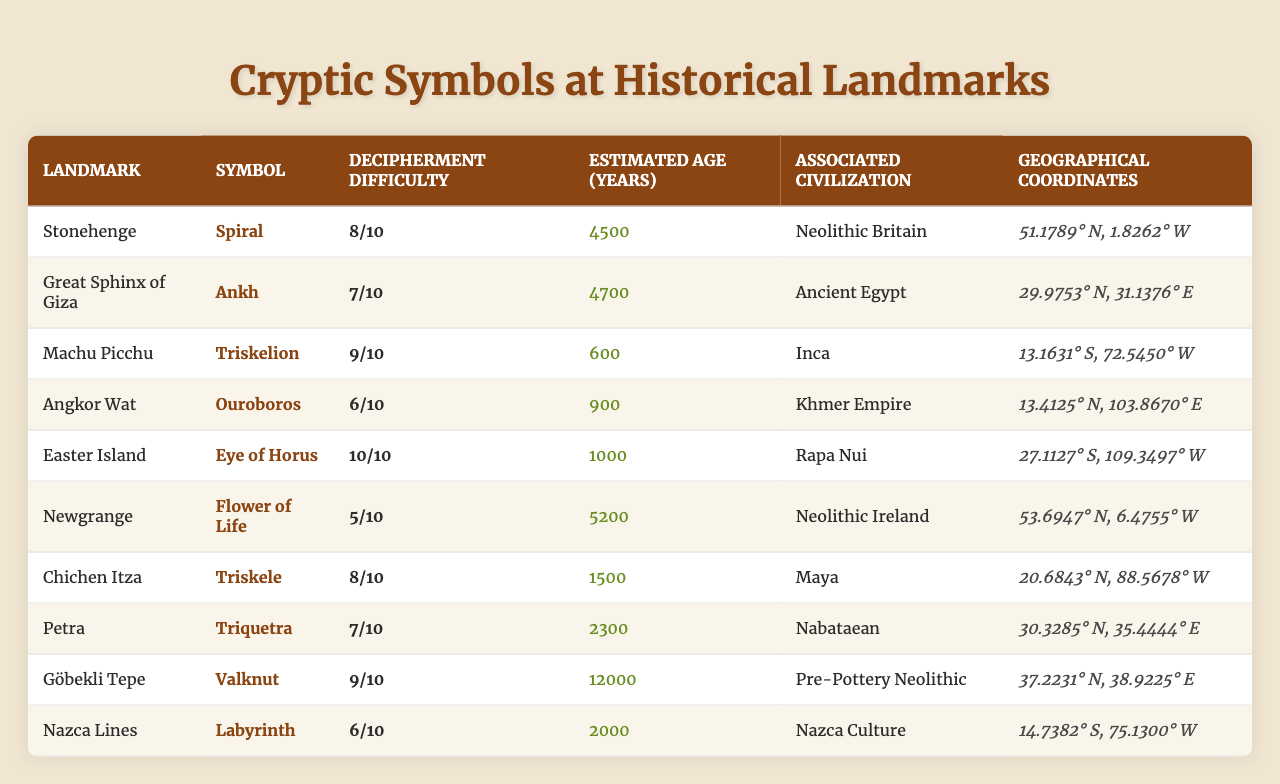What is the symbol associated with Machu Picchu? The table shows that the symbol next to Machu Picchu is "Triskelion".
Answer: Triskelion Which landmark has the highest decipherment difficulty? From the difficulties listed, the highest value is 10, which is associated with Easter Island.
Answer: Easter Island What is the average estimated age of the landmarks listed? Adding the ages (4500 + 4700 + 600 + 900 + 1000 + 5200 + 1500 + 2300 + 12000 + 2000) gives a total of 36,700. Dividing by the number of landmarks (10) results in an average age of 3670 years.
Answer: 3670 Which civilization is associated with the symbol "Flower of Life"? By checking the table, "Flower of Life" is linked to Newgrange, which corresponds to Neolithic Ireland.
Answer: Neolithic Ireland Are there any landmarks from the Maya civilization? Yes, Chichen Itza is associated with the Maya civilization, indicating a landmark from this culture exists in the table.
Answer: Yes What is the difference in estimated age between Petra and the Great Sphinx of Giza? Looking at their ages, Petra is 2300 years old and the Great Sphinx of Giza is 4700 years. The difference is 4700 - 2300 = 2400 years.
Answer: 2400 What is the symbol found at Stonehenge and what is its decipherment difficulty? The symbol at Stonehenge is "Spiral", and it has a decipherment difficulty of 8 out of 10.
Answer: Spiral, 8 Which two landmarks have a decipherment difficulty of 7? The landmarks with a difficulty of 7 are the Great Sphinx of Giza and Chichen Itza.
Answer: Great Sphinx of Giza, Chichen Itza Is the Eye of Horus associated with an older landmark than the Triskelion? The Eye of Horus is linked to the Great Sphinx of Giza, which is 4700 years old, while the Triskelion is linked to Machu Picchu at 600 years old. Since 4700 years is older than 600 years, the statement is true.
Answer: Yes What are the geographical coordinates of the Nazca Lines? The table provides the coordinates for Nazca Lines as 14.7382° S, 75.1300° W.
Answer: 14.7382° S, 75.1300° W 